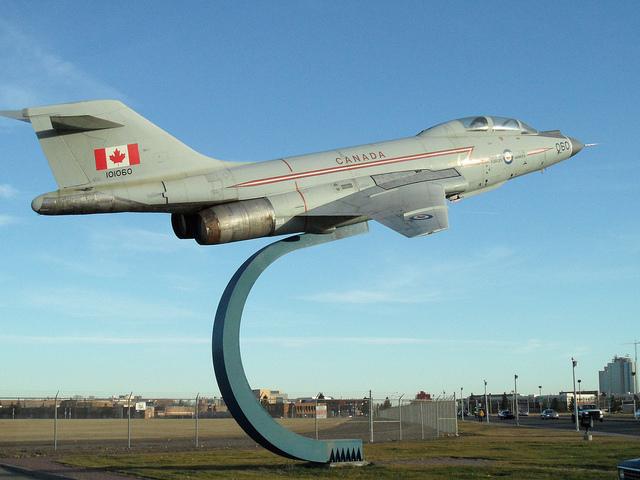What kind of leaf is on the tail of the plane?
Be succinct. Maple. The plane's stand resembles what letter?
Write a very short answer. C. What country is the plane from?
Concise answer only. Canada. 